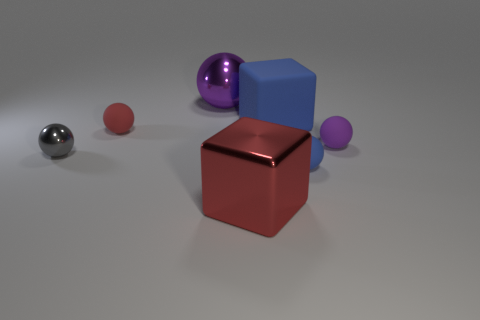There is a thing that is both on the right side of the red shiny block and in front of the gray object; what is its color?
Your answer should be compact. Blue. There is a purple metallic thing that is the same size as the red cube; what is its shape?
Keep it short and to the point. Sphere. Is there a ball of the same color as the rubber block?
Offer a terse response. Yes. Is the number of tiny rubber objects left of the small red thing the same as the number of gray shiny objects?
Your answer should be compact. No. What size is the ball that is to the left of the purple rubber thing and to the right of the big purple sphere?
Provide a succinct answer. Small. There is a large ball that is made of the same material as the small gray ball; what is its color?
Your answer should be very brief. Purple. How many other gray things are made of the same material as the tiny gray thing?
Give a very brief answer. 0. Are there the same number of small blue balls that are behind the small shiny sphere and tiny purple balls in front of the big purple metal thing?
Offer a terse response. No. Does the tiny purple thing have the same shape as the purple thing that is behind the big rubber cube?
Keep it short and to the point. Yes. Are there any other things that have the same shape as the gray object?
Provide a succinct answer. Yes. 